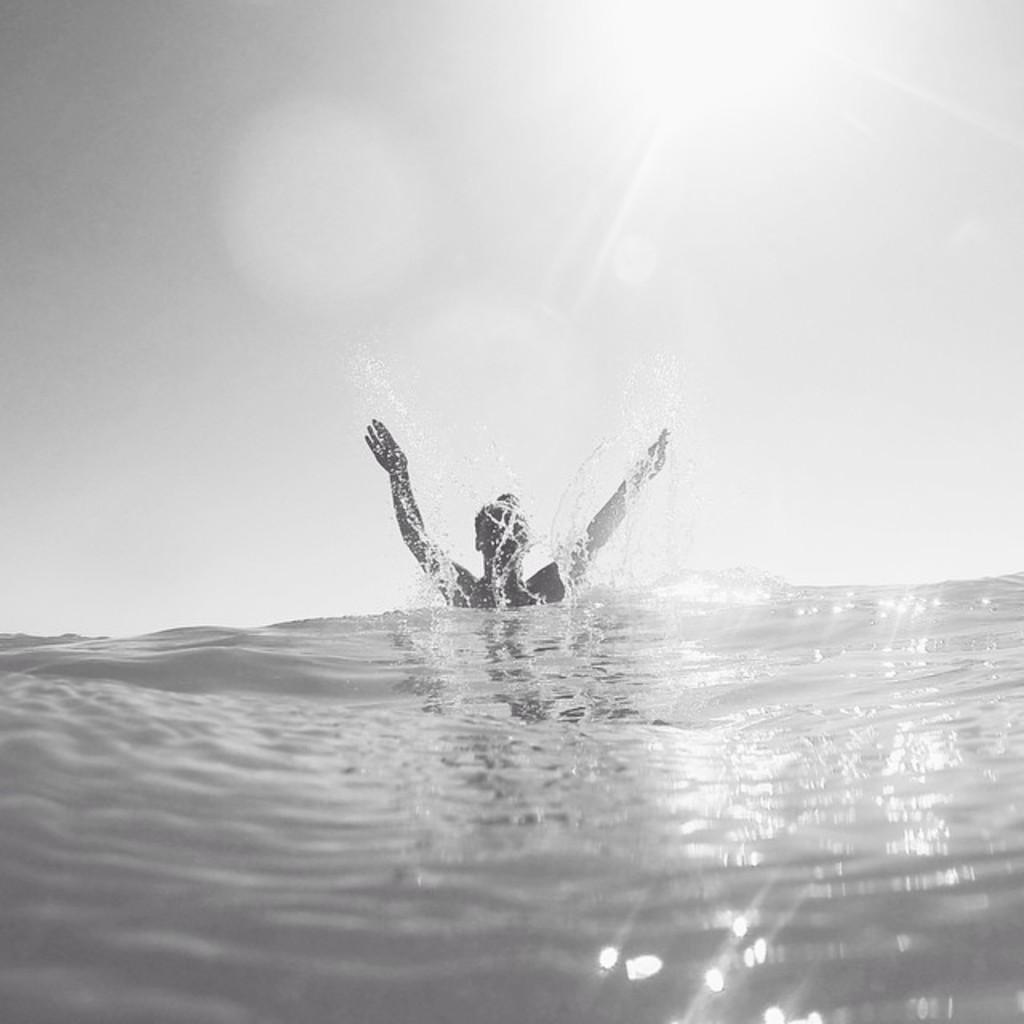Can you describe this image briefly? This is a black and white image. In this image we can see a man in a water body. We can also see the sky which looks cloudy. 